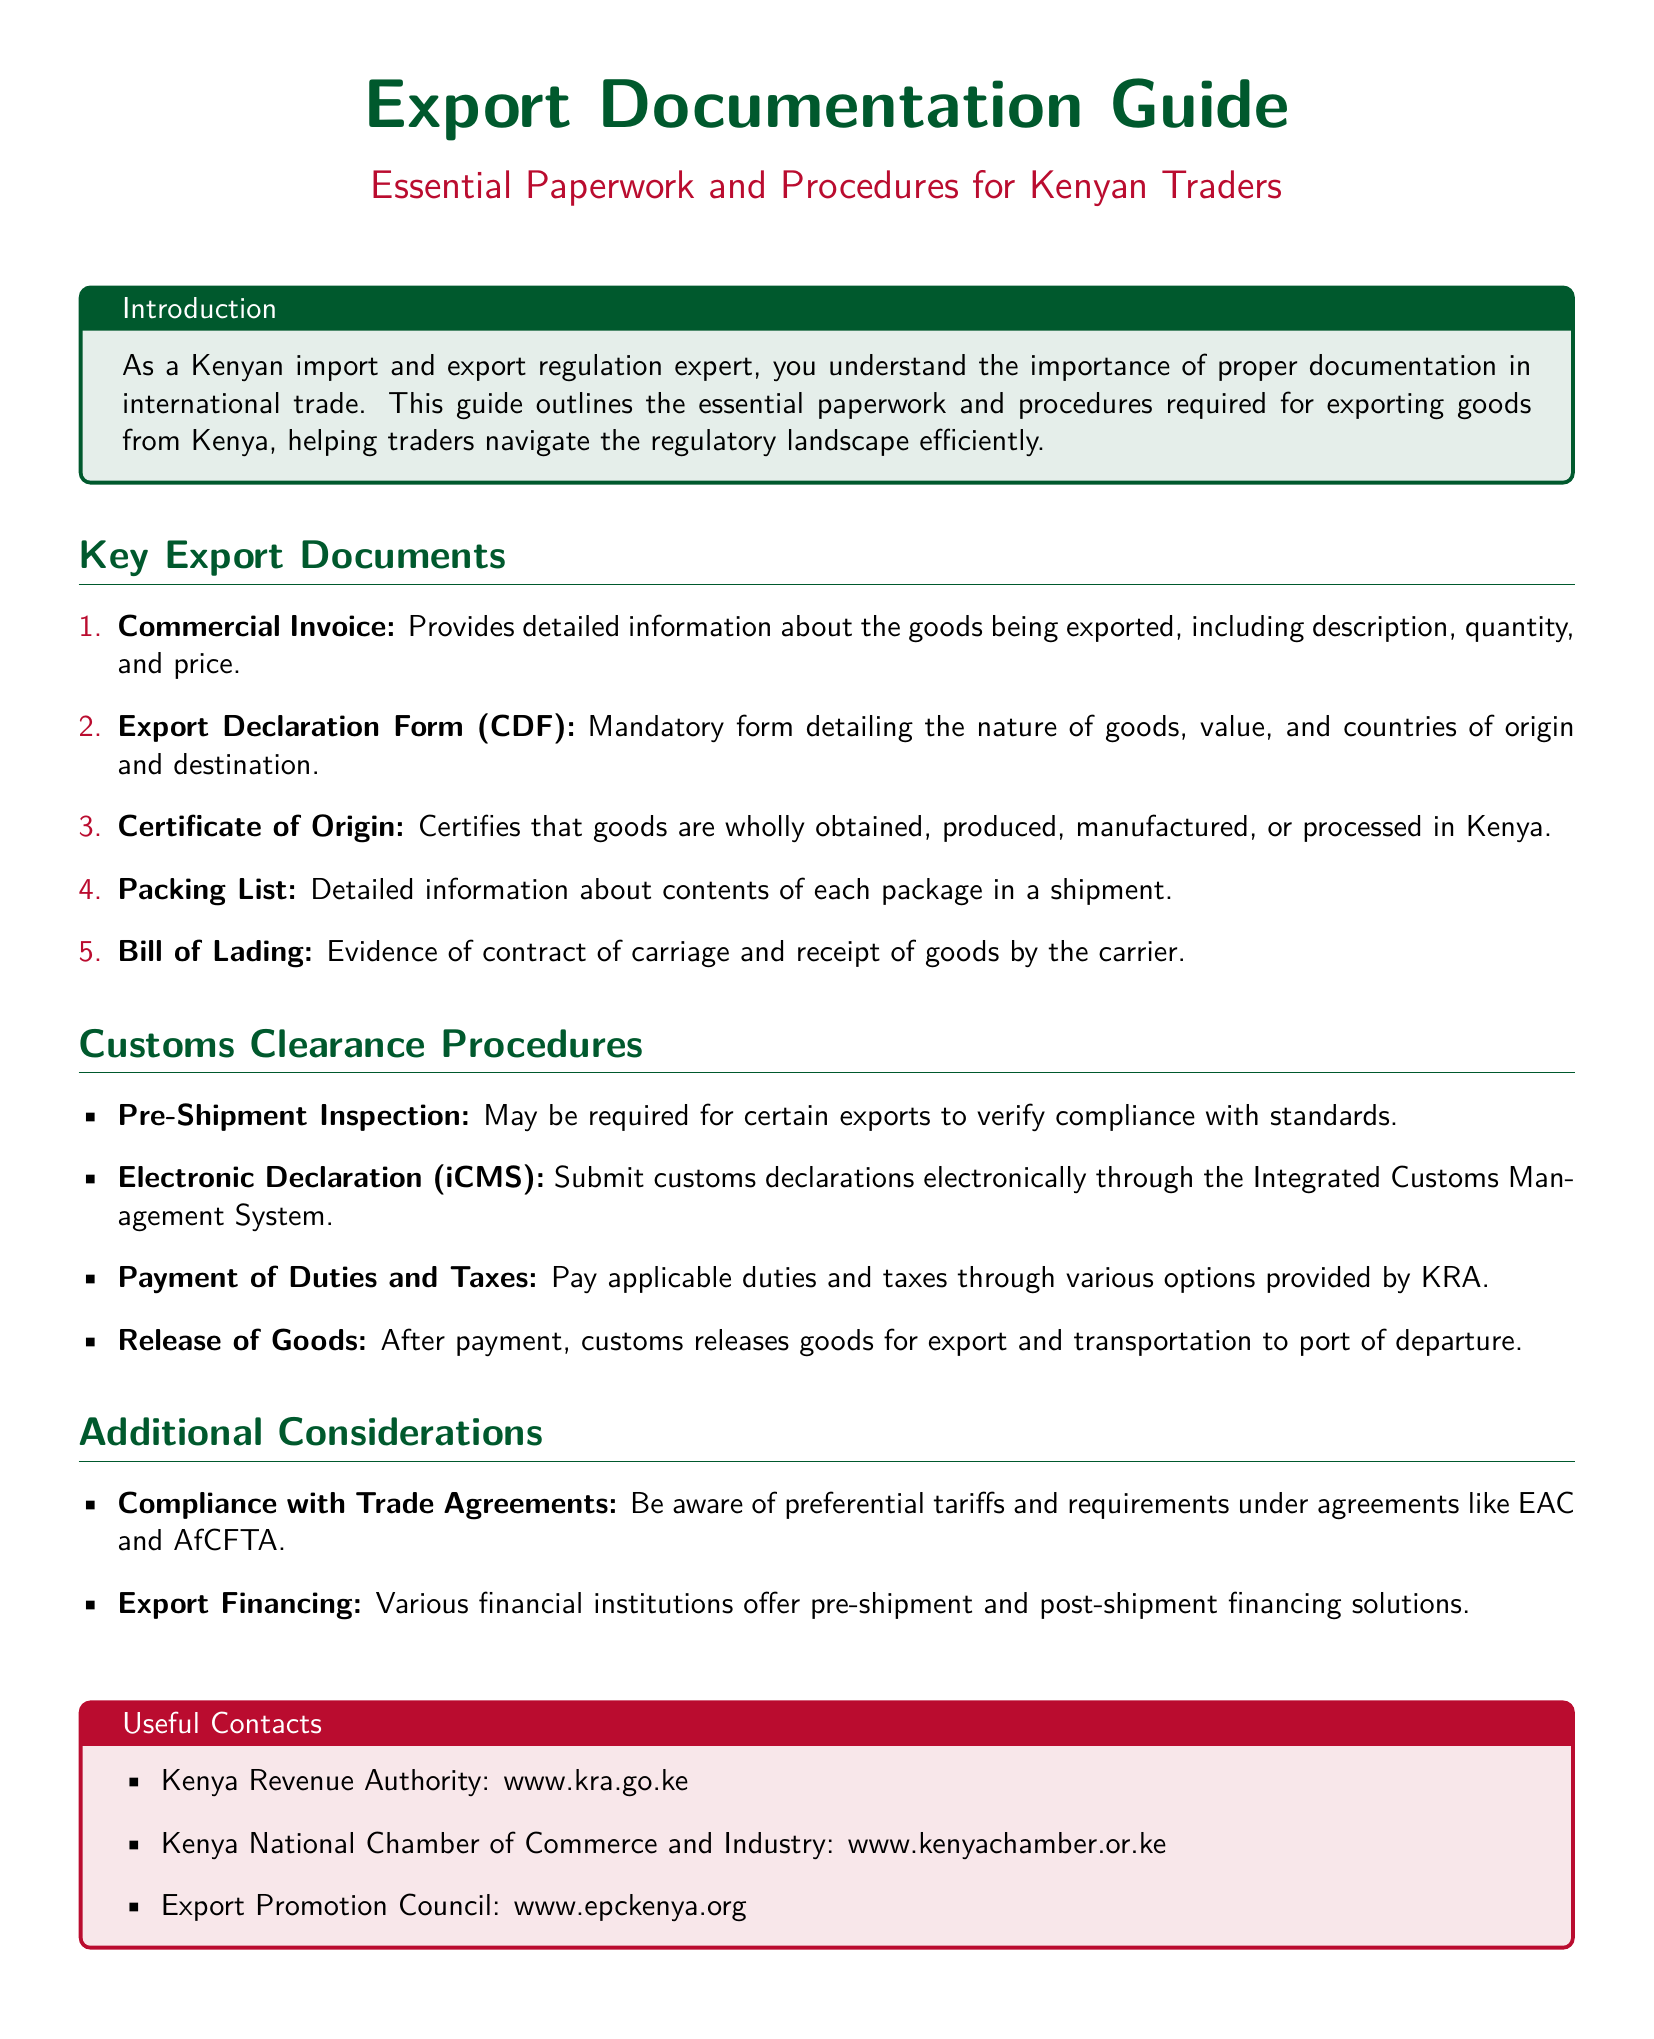what is the total number of key export documents listed? The document lists five key export documents under the section “Key Export Documents.”
Answer: 5 what is the main purpose of the Export Declaration Form (CDF)? The Export Declaration Form (CDF) is mandatory and details the nature of goods, value, and countries of origin and destination.
Answer: Detail the nature of goods which document certifies that goods are produced in Kenya? The document that certifies that goods are produced in Kenya is the Certificate of Origin.
Answer: Certificate of Origin what procedure is required before the goods are exported? A pre-shipment inspection may be required for certain exports.
Answer: Pre-shipment inspection what payment is necessary for customs clearance? Payment of applicable duties and taxes is necessary for customs clearance.
Answer: Duties and taxes name one organization mentioned for useful contacts. The document mentions several organizations; one of them is the Kenya Revenue Authority.
Answer: Kenya Revenue Authority what does the acronym KRA stand for? KRA is an abbreviation for Kenya Revenue Authority.
Answer: Kenya Revenue Authority under which agreements should traders be compliant? Traders should be aware of compliance with trade agreements such as EAC and AfCFTA.
Answer: EAC and AfCFTA how should customs declarations be submitted? Customs declarations should be submitted electronically through the Integrated Customs Management System.
Answer: Electronically through iCMS 